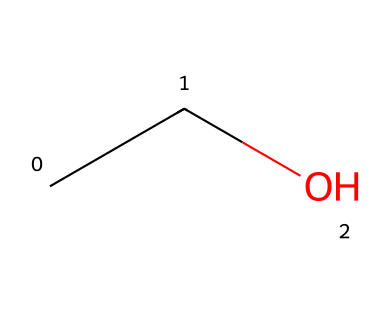What is the molecular formula of ethanol? The SMILES representation "CCO" indicates that there are two carbon atoms, six hydrogen atoms, and one oxygen atom, which together form the molecular formula C2H6O for ethanol.
Answer: C2H6O How many total atoms are in ethanol? By analyzing the molecular formula C2H6O, we count 2 carbon atoms, 6 hydrogen atoms, and 1 oxygen atom, leading to a total of 2 + 6 + 1 = 9 atoms.
Answer: 9 What type of functional group is present in ethanol? The "O" in the SMILES structure "CCO" indicates the presence of a hydroxyl (-OH) group, classifying ethanol as an alcohol due to this functional group.
Answer: alcohol What is the degree of saturation in ethanol? Ethanol has a single bond between carbon atoms and includes no rings or multiple bonds. Thus, its degree of saturation is 1 (indicating it's saturated with hydrogen).
Answer: 1 Does ethanol contain any double or triple bonds? The structure "CCO" shows only single bonds between the carbon atoms and to the oxygen, confirming that ethanol contains no double or triple bonds.
Answer: no What classification does ethanol fall under in terms of aliphatic compounds? Ethanol, being a straight-chain compound with no rings, is classified as a linear or unbranched aliphatic compound.
Answer: linear How many hydrogen atoms are attached to each carbon in ethanol? In the structure "CCO," each carbon is bonded to enough hydrogen atoms to satisfy carbon's four-bond requirement: the first carbon has 3 hydrogens, and the second carbon has 2.
Answer: 3 and 2 